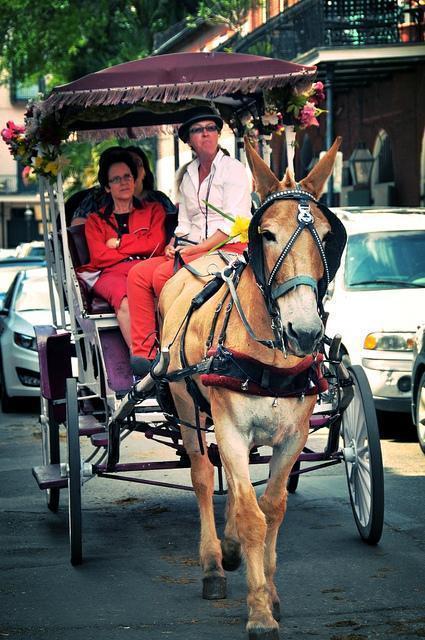What is this horse being used for?
Indicate the correct response by choosing from the four available options to answer the question.
Options: Consumption, transportation, companionship, riding. Transportation. 